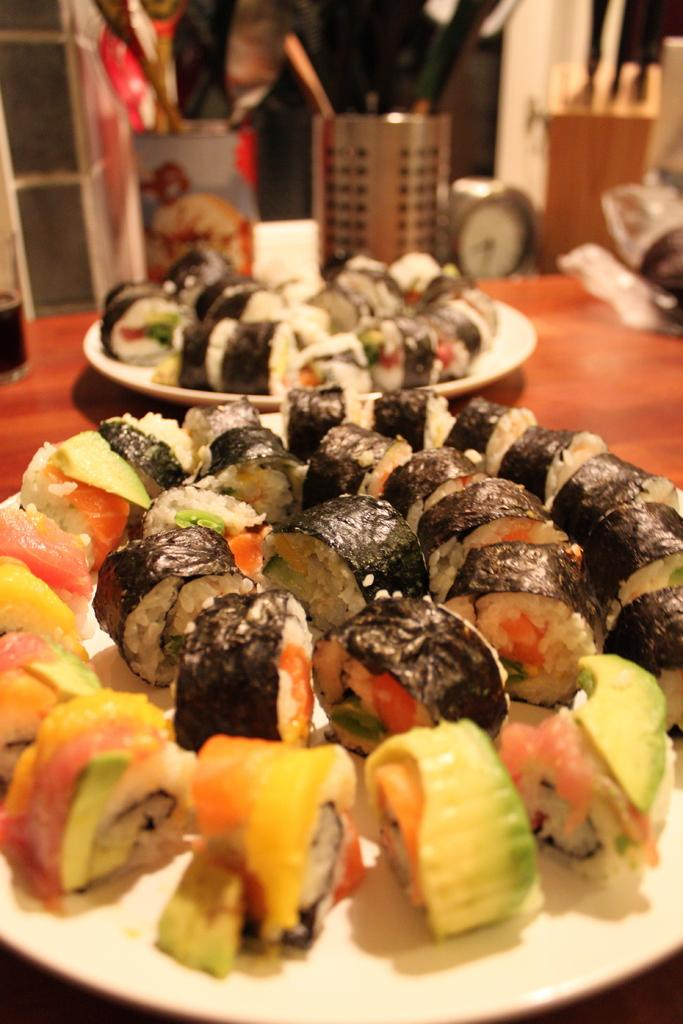What piece of furniture is present in the image? There is a table in the image. What is placed on the table? There are two plates with food items on the table. What utensils are available for use in the image? There are two stands with spoons and knives in the image. What time-related object is visible in the image? There is a clock visible in the image. What type of star is visible in the image? There is no star visible in the image; it only contains a table, plates with food items, utensil stands, and a clock. 